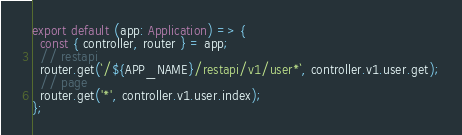<code> <loc_0><loc_0><loc_500><loc_500><_TypeScript_>export default (app: Application) => {
  const { controller, router } = app;
  // restapi
  router.get(`/${APP_NAME}/restapi/v1/user*`, controller.v1.user.get);
  // page
  router.get('*', controller.v1.user.index);
};
</code> 